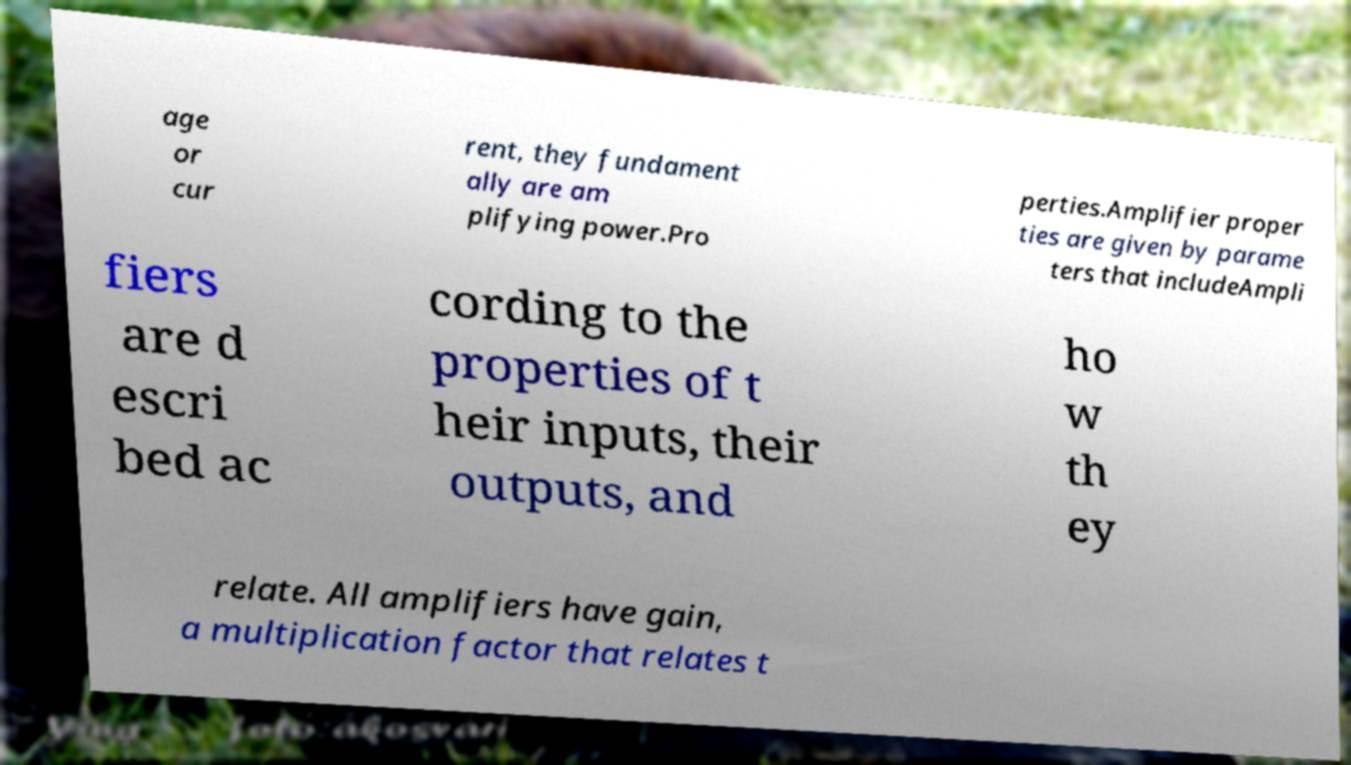Can you accurately transcribe the text from the provided image for me? age or cur rent, they fundament ally are am plifying power.Pro perties.Amplifier proper ties are given by parame ters that includeAmpli fiers are d escri bed ac cording to the properties of t heir inputs, their outputs, and ho w th ey relate. All amplifiers have gain, a multiplication factor that relates t 